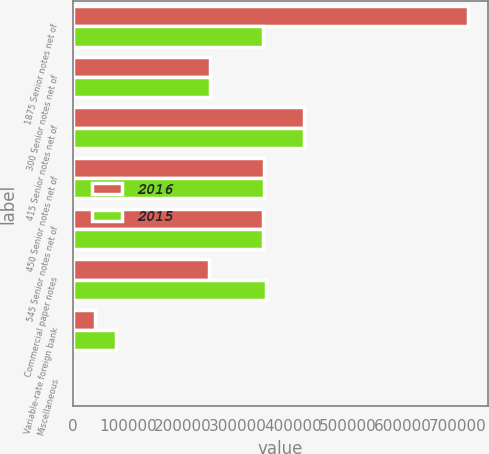<chart> <loc_0><loc_0><loc_500><loc_500><stacked_bar_chart><ecel><fcel>1875 Senior notes net of<fcel>300 Senior notes net of<fcel>415 Senior notes net of<fcel>450 Senior notes net of<fcel>545 Senior notes net of<fcel>Commercial paper notes<fcel>Variable-rate foreign bank<fcel>Miscellaneous<nl><fcel>2016<fcel>719617<fcel>248714<fcel>421141<fcel>347620<fcel>345687<fcel>247503<fcel>38939<fcel>41<nl><fcel>2015<fcel>345532<fcel>248274<fcel>420654<fcel>347018<fcel>345532<fcel>351349<fcel>77452<fcel>81<nl></chart> 